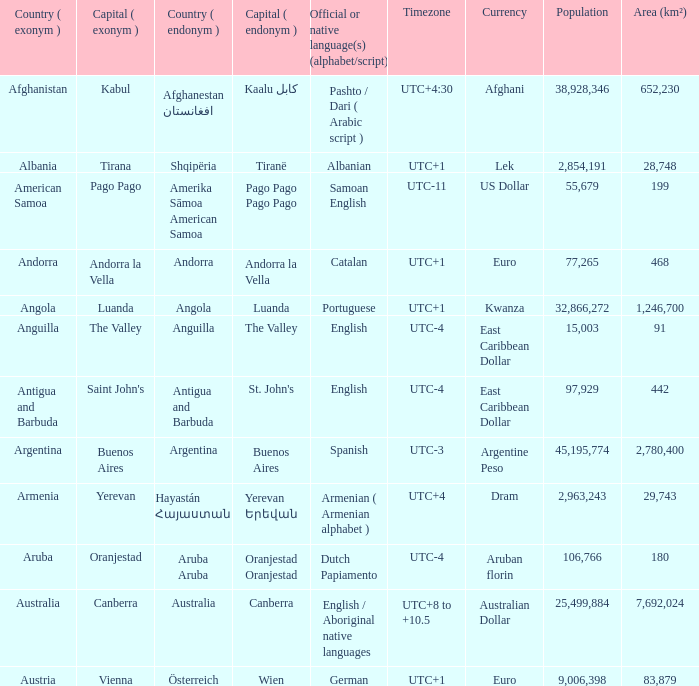What official or native languages are spoken in the country whose capital city is Canberra? English / Aboriginal native languages. 